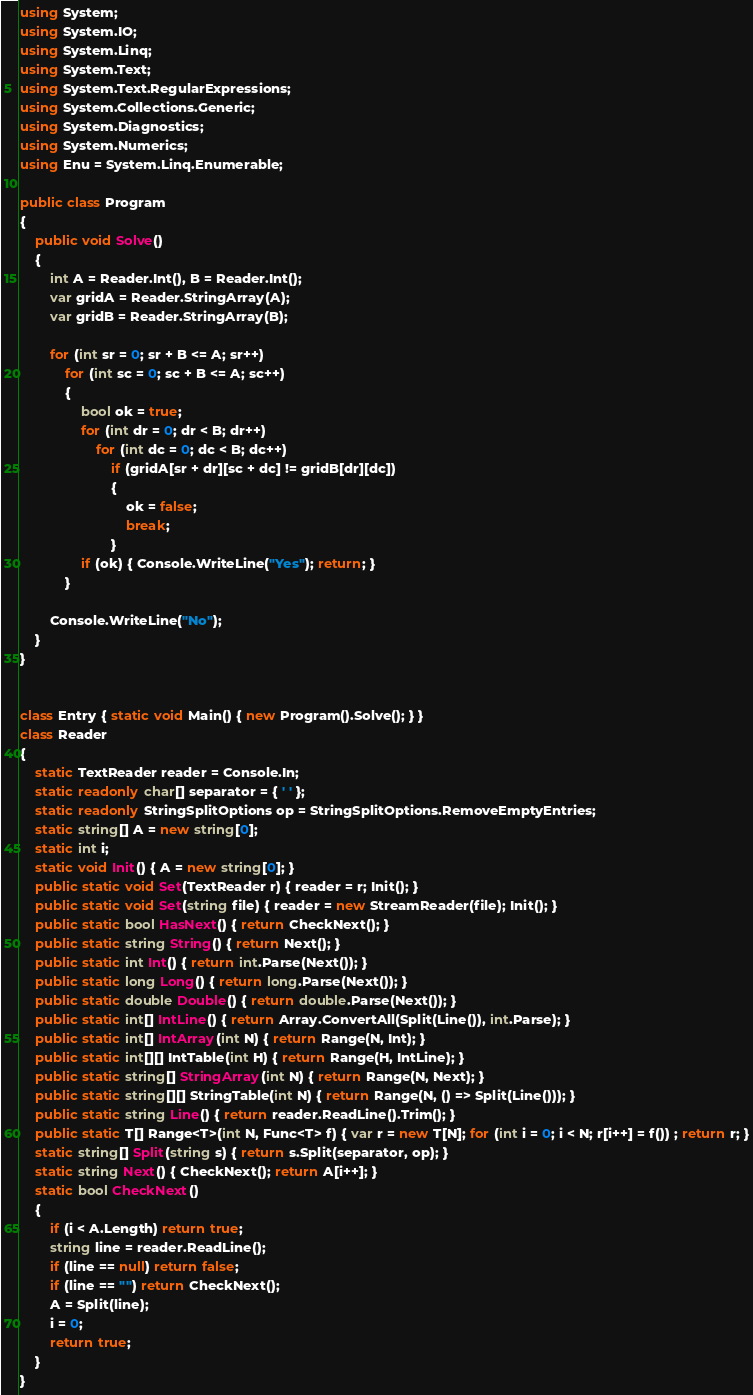Convert code to text. <code><loc_0><loc_0><loc_500><loc_500><_C#_>using System;
using System.IO;
using System.Linq;
using System.Text;
using System.Text.RegularExpressions;
using System.Collections.Generic;
using System.Diagnostics;
using System.Numerics;
using Enu = System.Linq.Enumerable;

public class Program
{
    public void Solve()
    {
        int A = Reader.Int(), B = Reader.Int();
        var gridA = Reader.StringArray(A);
        var gridB = Reader.StringArray(B);

        for (int sr = 0; sr + B <= A; sr++)
            for (int sc = 0; sc + B <= A; sc++)
            {
                bool ok = true;
                for (int dr = 0; dr < B; dr++)
                    for (int dc = 0; dc < B; dc++)
                        if (gridA[sr + dr][sc + dc] != gridB[dr][dc])
                        {
                            ok = false;
                            break;
                        }
                if (ok) { Console.WriteLine("Yes"); return; }
            }

        Console.WriteLine("No");
    }
}


class Entry { static void Main() { new Program().Solve(); } }
class Reader
{
    static TextReader reader = Console.In;
    static readonly char[] separator = { ' ' };
    static readonly StringSplitOptions op = StringSplitOptions.RemoveEmptyEntries;
    static string[] A = new string[0];
    static int i;
    static void Init() { A = new string[0]; }
    public static void Set(TextReader r) { reader = r; Init(); }
    public static void Set(string file) { reader = new StreamReader(file); Init(); }
    public static bool HasNext() { return CheckNext(); }
    public static string String() { return Next(); }
    public static int Int() { return int.Parse(Next()); }
    public static long Long() { return long.Parse(Next()); }
    public static double Double() { return double.Parse(Next()); }
    public static int[] IntLine() { return Array.ConvertAll(Split(Line()), int.Parse); }
    public static int[] IntArray(int N) { return Range(N, Int); }
    public static int[][] IntTable(int H) { return Range(H, IntLine); }
    public static string[] StringArray(int N) { return Range(N, Next); }
    public static string[][] StringTable(int N) { return Range(N, () => Split(Line())); }
    public static string Line() { return reader.ReadLine().Trim(); }
    public static T[] Range<T>(int N, Func<T> f) { var r = new T[N]; for (int i = 0; i < N; r[i++] = f()) ; return r; }
    static string[] Split(string s) { return s.Split(separator, op); }
    static string Next() { CheckNext(); return A[i++]; }
    static bool CheckNext()
    {
        if (i < A.Length) return true;
        string line = reader.ReadLine();
        if (line == null) return false;
        if (line == "") return CheckNext();
        A = Split(line);
        i = 0;
        return true;
    }
}</code> 